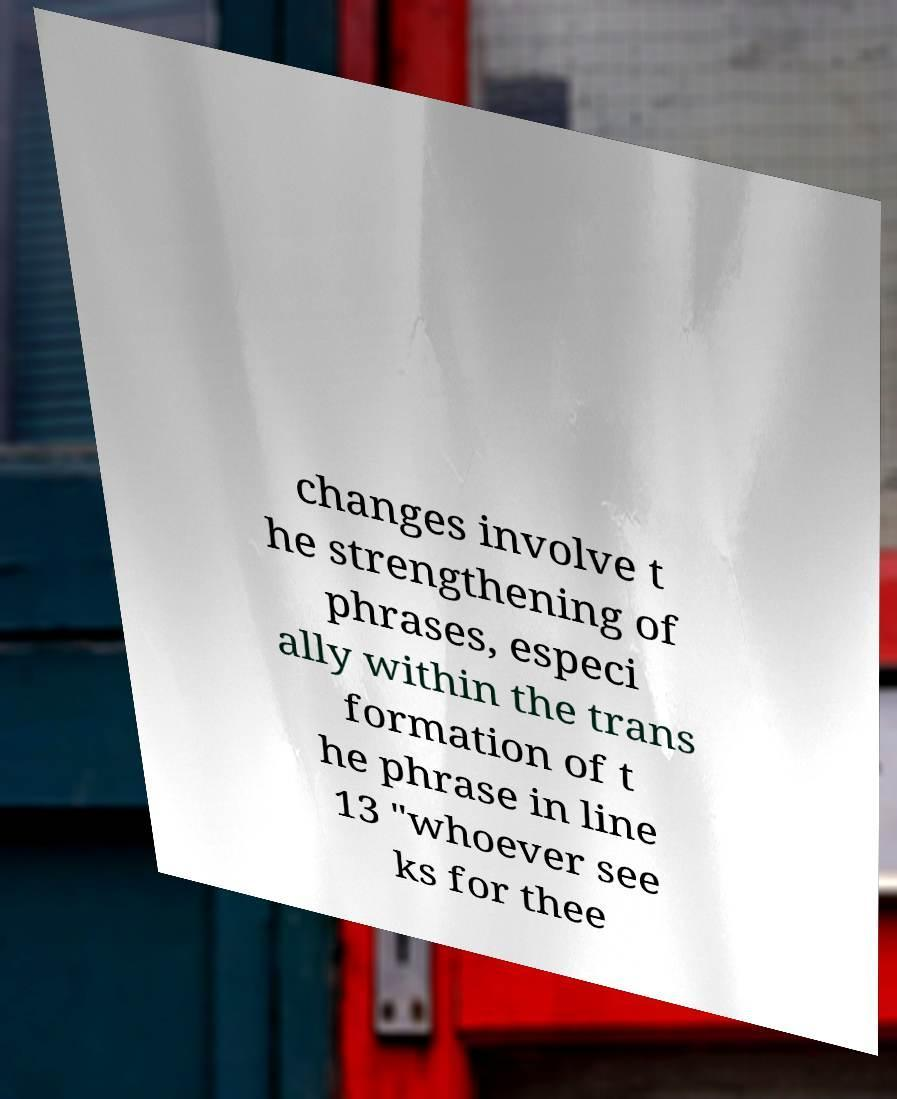Can you accurately transcribe the text from the provided image for me? changes involve t he strengthening of phrases, especi ally within the trans formation of t he phrase in line 13 "whoever see ks for thee 